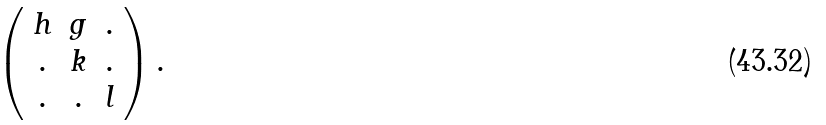<formula> <loc_0><loc_0><loc_500><loc_500>\left ( \begin{array} { c c c } h & g & . \\ . & k & . \\ . & . & l \end{array} \right ) .</formula> 